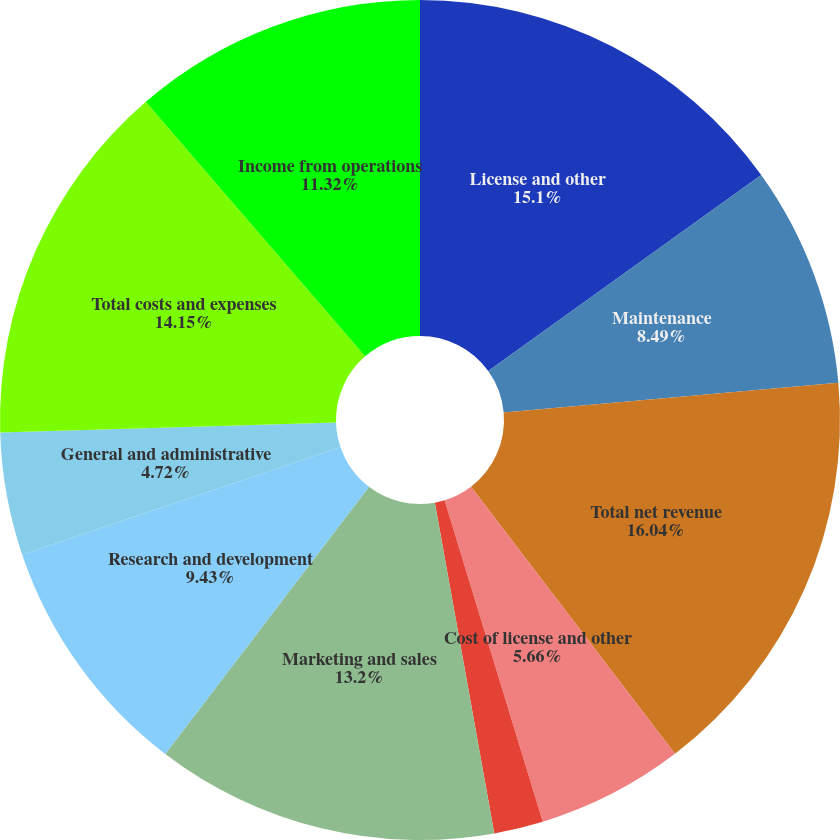<chart> <loc_0><loc_0><loc_500><loc_500><pie_chart><fcel>License and other<fcel>Maintenance<fcel>Total net revenue<fcel>Cost of license and other<fcel>Cost of maintenance revenue<fcel>Marketing and sales<fcel>Research and development<fcel>General and administrative<fcel>Total costs and expenses<fcel>Income from operations<nl><fcel>15.09%<fcel>8.49%<fcel>16.03%<fcel>5.66%<fcel>1.89%<fcel>13.2%<fcel>9.43%<fcel>4.72%<fcel>14.15%<fcel>11.32%<nl></chart> 